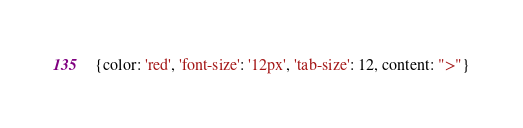<code> <loc_0><loc_0><loc_500><loc_500><_JavaScript_>{color: 'red', 'font-size': '12px', 'tab-size': 12, content: ">"}
</code> 